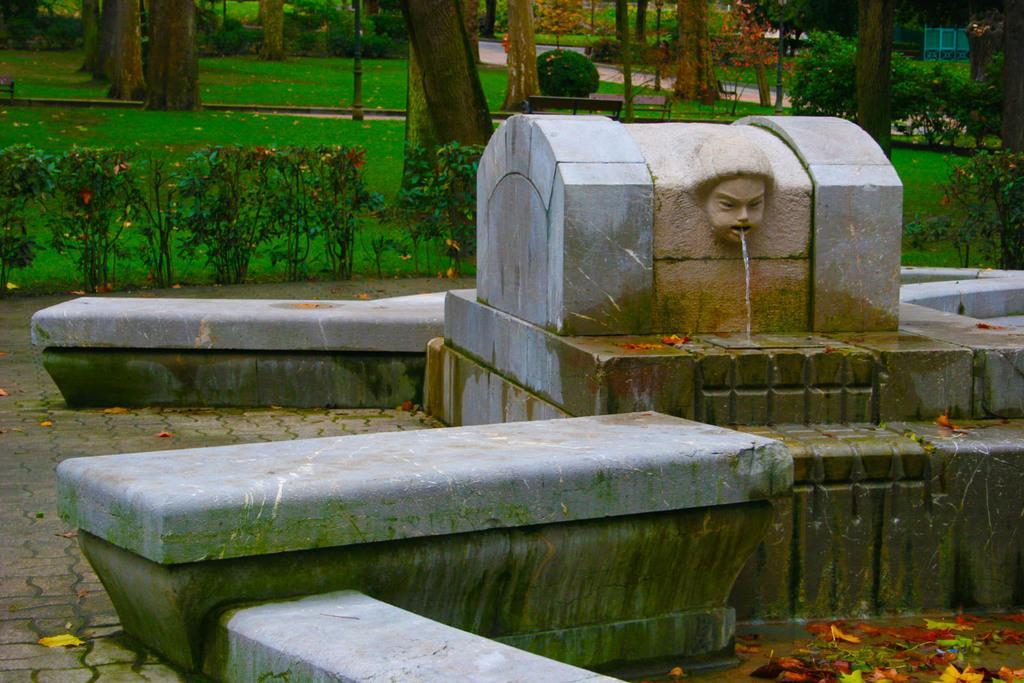Describe this image in one or two sentences. Here we can see water coming out from a sculpture. There are plants and this is grass. Here we can see a bench and trees. 